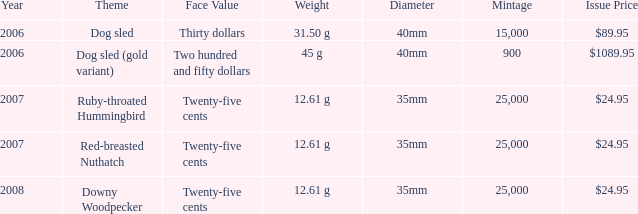Could you parse the entire table? {'header': ['Year', 'Theme', 'Face Value', 'Weight', 'Diameter', 'Mintage', 'Issue Price'], 'rows': [['2006', 'Dog sled', 'Thirty dollars', '31.50 g', '40mm', '15,000', '$89.95'], ['2006', 'Dog sled (gold variant)', 'Two hundred and fifty dollars', '45 g', '40mm', '900', '$1089.95'], ['2007', 'Ruby-throated Hummingbird', 'Twenty-five cents', '12.61 g', '35mm', '25,000', '$24.95'], ['2007', 'Red-breasted Nuthatch', 'Twenty-five cents', '12.61 g', '35mm', '25,000', '$24.95'], ['2008', 'Downy Woodpecker', 'Twenty-five cents', '12.61 g', '35mm', '25,000', '$24.95']]} What is the central subject of the coin priced at $89.95? Dog sled. 